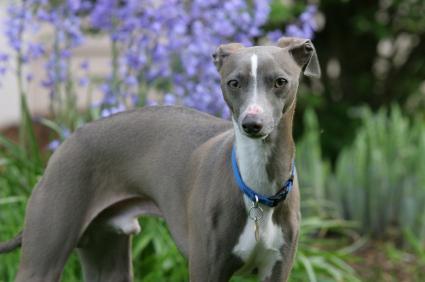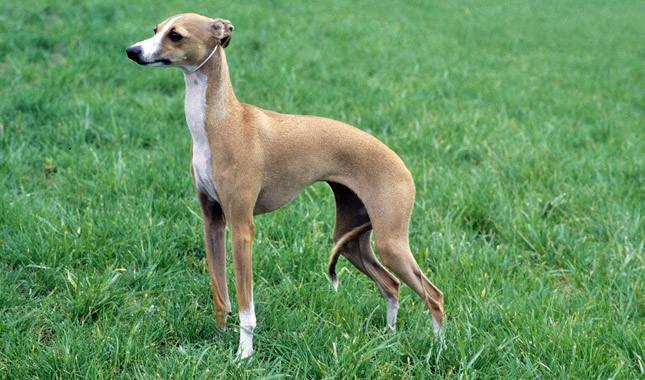The first image is the image on the left, the second image is the image on the right. Analyze the images presented: Is the assertion "At least one image shows a grey dog wearing a color." valid? Answer yes or no. Yes. 